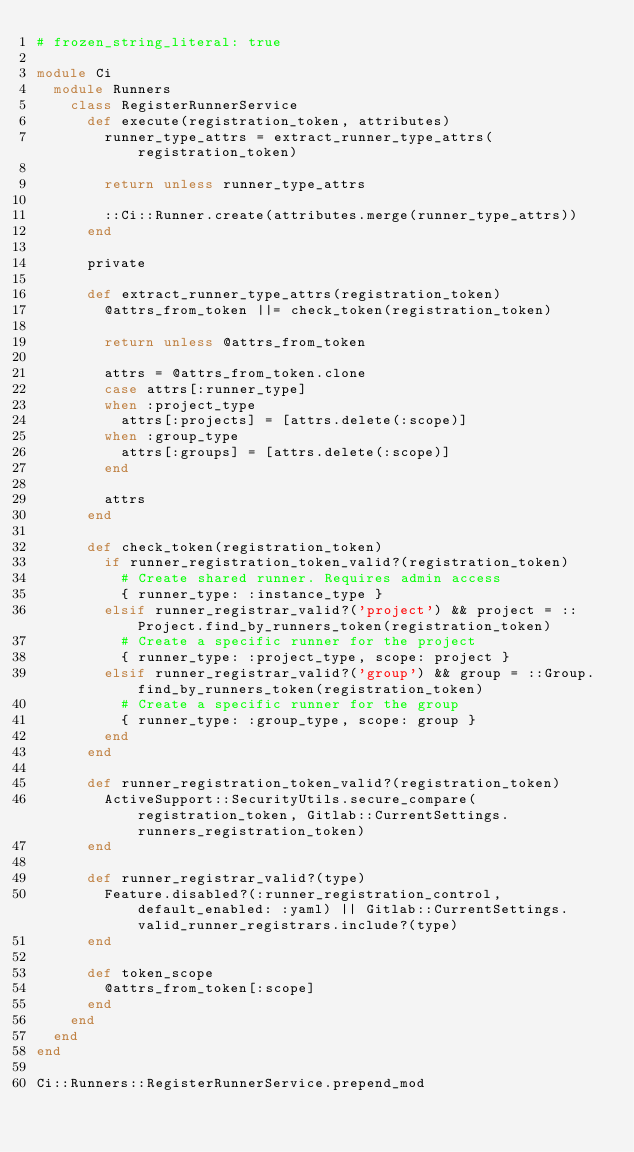<code> <loc_0><loc_0><loc_500><loc_500><_Ruby_># frozen_string_literal: true

module Ci
  module Runners
    class RegisterRunnerService
      def execute(registration_token, attributes)
        runner_type_attrs = extract_runner_type_attrs(registration_token)

        return unless runner_type_attrs

        ::Ci::Runner.create(attributes.merge(runner_type_attrs))
      end

      private

      def extract_runner_type_attrs(registration_token)
        @attrs_from_token ||= check_token(registration_token)

        return unless @attrs_from_token

        attrs = @attrs_from_token.clone
        case attrs[:runner_type]
        when :project_type
          attrs[:projects] = [attrs.delete(:scope)]
        when :group_type
          attrs[:groups] = [attrs.delete(:scope)]
        end

        attrs
      end

      def check_token(registration_token)
        if runner_registration_token_valid?(registration_token)
          # Create shared runner. Requires admin access
          { runner_type: :instance_type }
        elsif runner_registrar_valid?('project') && project = ::Project.find_by_runners_token(registration_token)
          # Create a specific runner for the project
          { runner_type: :project_type, scope: project }
        elsif runner_registrar_valid?('group') && group = ::Group.find_by_runners_token(registration_token)
          # Create a specific runner for the group
          { runner_type: :group_type, scope: group }
        end
      end

      def runner_registration_token_valid?(registration_token)
        ActiveSupport::SecurityUtils.secure_compare(registration_token, Gitlab::CurrentSettings.runners_registration_token)
      end

      def runner_registrar_valid?(type)
        Feature.disabled?(:runner_registration_control, default_enabled: :yaml) || Gitlab::CurrentSettings.valid_runner_registrars.include?(type)
      end

      def token_scope
        @attrs_from_token[:scope]
      end
    end
  end
end

Ci::Runners::RegisterRunnerService.prepend_mod
</code> 